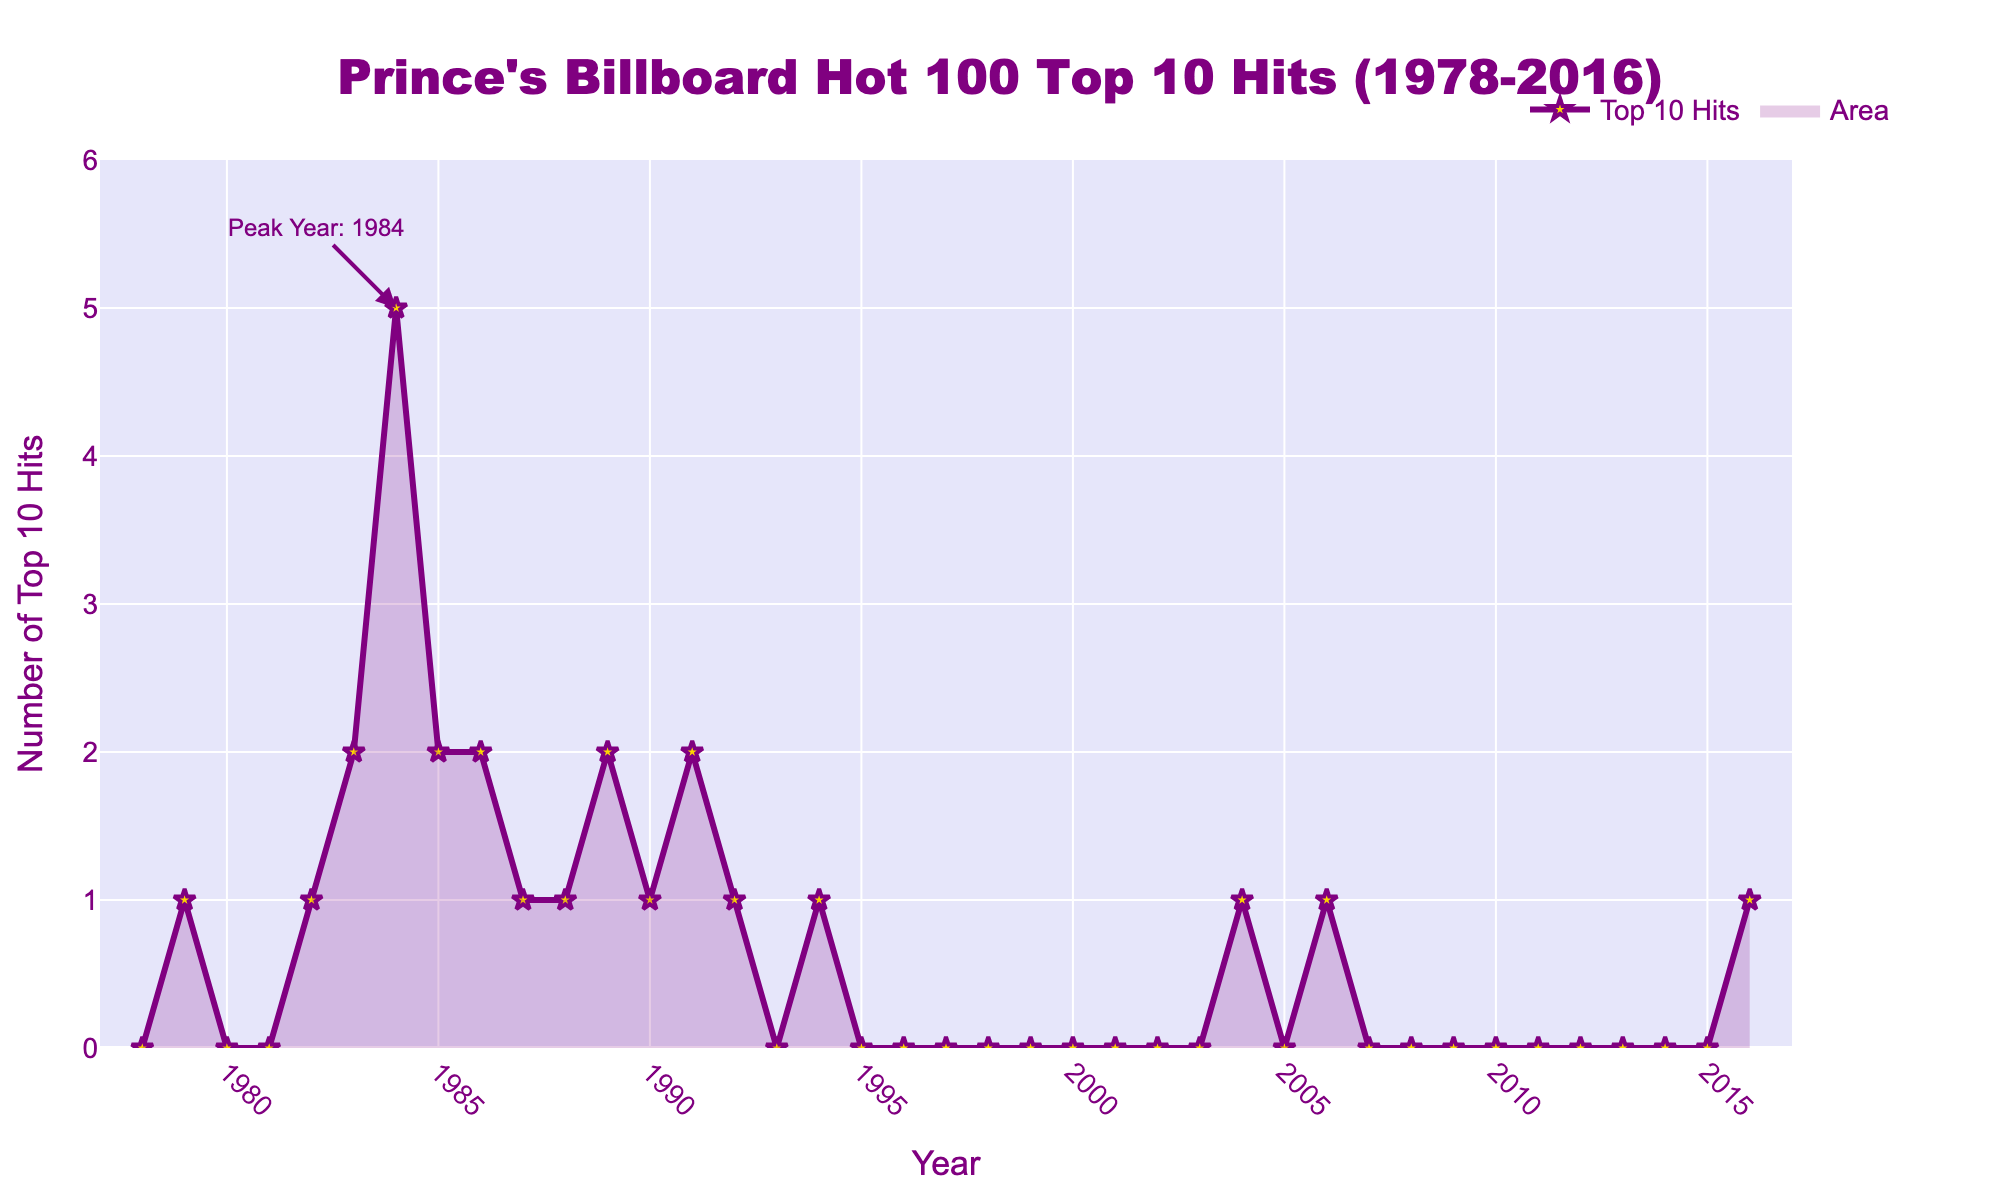When did Prince start having Top 10 Hits on Billboard Hot 100? According to the figure, Prince started having Top 10 Hits in the year 1979. This is evident from the rise in the line chart at 1979.
Answer: 1979 In which year did Prince have the highest number of Top 10 Hits? The peak of the chart occurs at the year 1984, where it is annotated as 'Peak Year: 1984' and the line reaches its maximum value of 5.
Answer: 1984 How many years did Prince have no Top 10 Hits between 1978 and 2016? Observing the chart, Prince had no Top 10 Hits in the years 1978, 1980, 1981, 1993, 1995-2003, 2005, 2007-2015, totaling 23 years without Top 10 Hits.
Answer: 23 years How many Top 10 Hits did Prince have in the 80s (1980-1989) in total? Summing the Top 10 Hits from the individual years (1980-1989): 0 + 0 + 1 + 2 + 5 + 2 + 2 + 1 + 1 + 2 gives a total of 16 Top 10 Hits.
Answer: 16 hits How many more Top 10 Hits did Prince have in 1984 compared to 1985? Prince had 5 Top 10 Hits in 1984 and 2 in 1985. The difference is 5 - 2 = 3.
Answer: 3 In how many years did Prince earn exactly 2 Top 10 Hits on Billboard Hot 100? Referring to the figure, in the years 1983, 1985, 1986, 1989, and 1991, Prince had exactly 2 Top 10 Hits. There are 5 such years.
Answer: 5 years What is the average number of Top 10 Hits Prince had per year from 2000 to 2016? The Top 10 Hits data from 2000 to 2016 are: 0, 0, 0, 0, 0, 0, 1, 0, 0, 0, 0, 0, 0, 0, 0, 0, 1. Summing these gives 2, and dividing by 17 years gives an average: 2 / 17 ≈ 0.12.
Answer: 0.12 Which decade had the most Top 10 Hits for Prince? By visually inspecting the chart, the 1980s (1980-1989) had the most total Top 10 Hits. Summing them gives 16, while the 1990s and 2000s had far fewer.
Answer: 1980s 